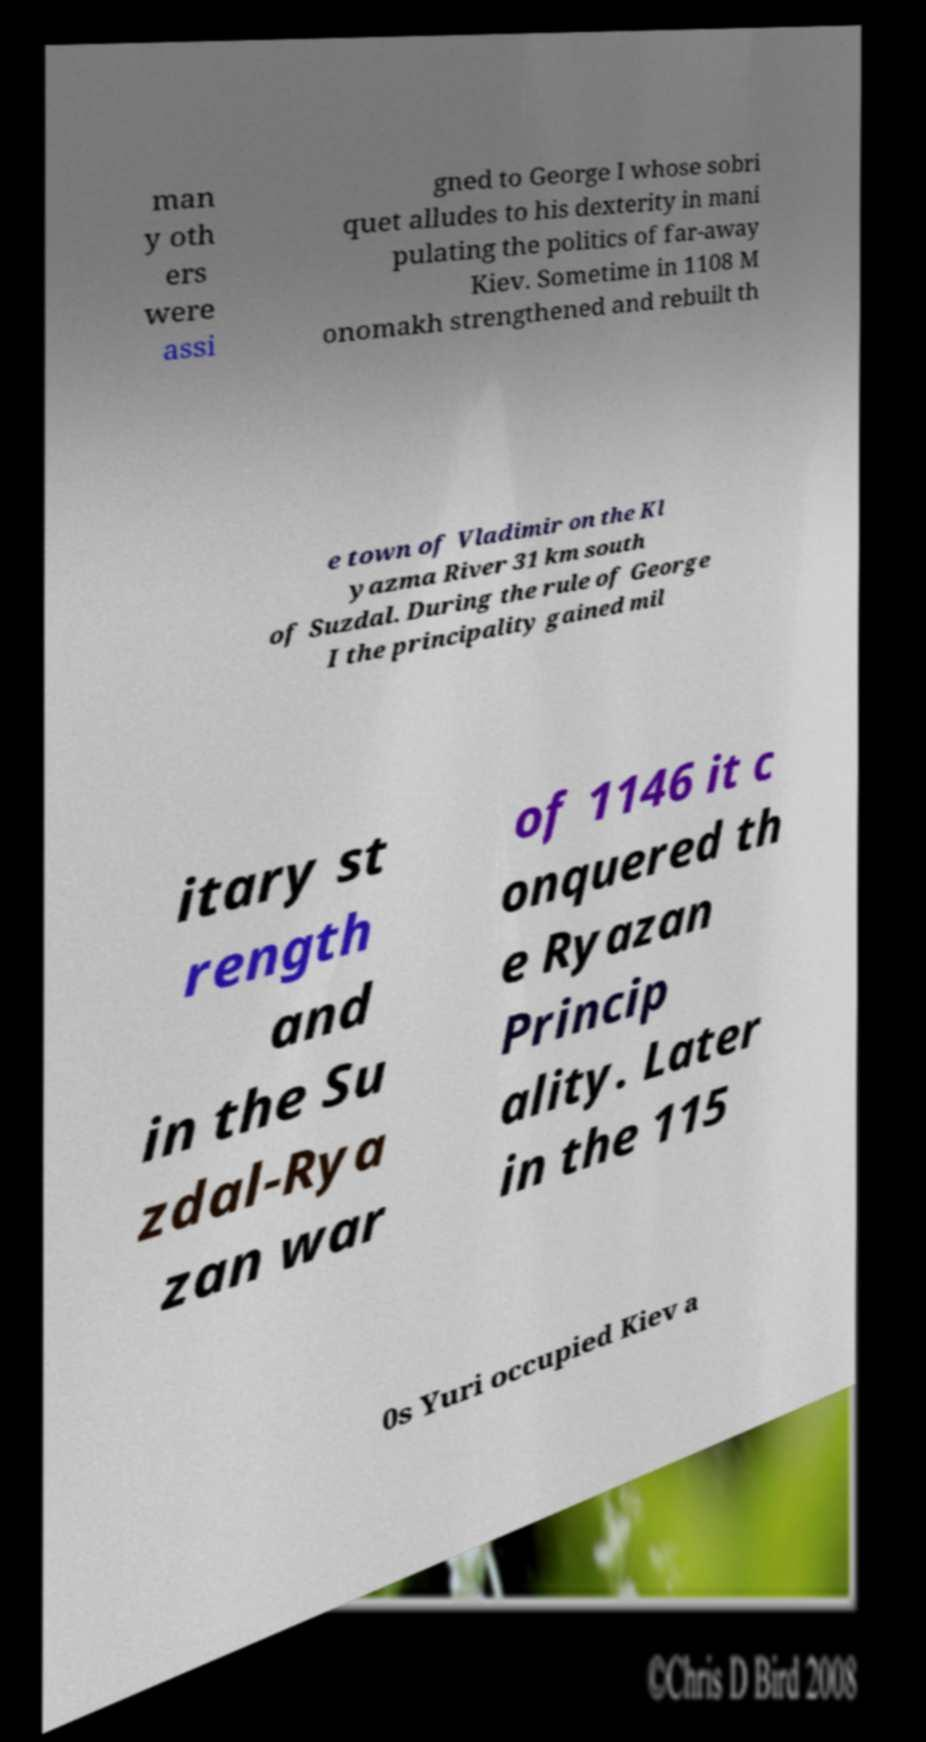Can you read and provide the text displayed in the image?This photo seems to have some interesting text. Can you extract and type it out for me? man y oth ers were assi gned to George I whose sobri quet alludes to his dexterity in mani pulating the politics of far-away Kiev. Sometime in 1108 M onomakh strengthened and rebuilt th e town of Vladimir on the Kl yazma River 31 km south of Suzdal. During the rule of George I the principality gained mil itary st rength and in the Su zdal-Rya zan war of 1146 it c onquered th e Ryazan Princip ality. Later in the 115 0s Yuri occupied Kiev a 